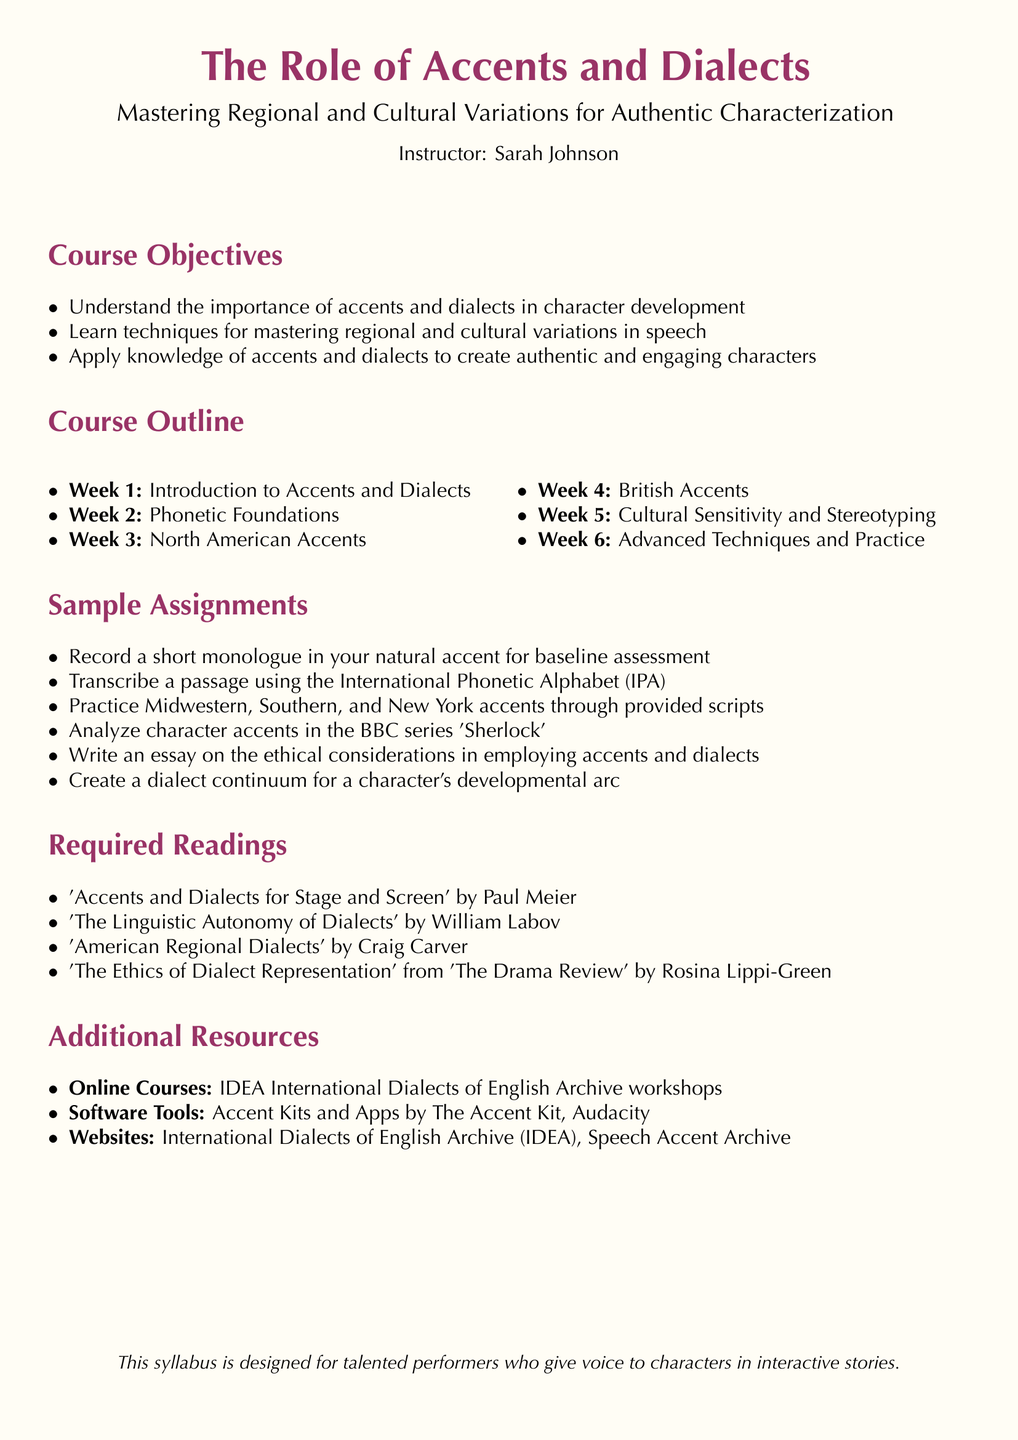What is the course title? The course title is listed at the top of the document, stating its focus on accents and dialects for performers.
Answer: The Role of Accents and Dialects Who is the instructor of the course? The instructor's name is mentioned under the course title, indicating who will lead the class.
Answer: Sarah Johnson How many weeks is the course designed for? The course outline lists weeks, which gives a clear number of instructional weeks in the syllabus.
Answer: 6 What is one of the sample assignments? A specific assignment is mentioned in the document that demonstrates what students are expected to complete as part of the course.
Answer: Record a short monologue in your natural accent for baseline assessment What is the first required reading? The syllabus includes a list of required readings, with the first title indicating an essential text for the course.
Answer: 'Accents and Dialects for Stage and Screen' by Paul Meier What week covers 'Cultural Sensitivity and Stereotyping'? The course outline breaks down topics by week, allowing us to identify when this theme is discussed.
Answer: Week 5 What type of resource are the Accent Kits classified as? The additional resources section categorizes resources to aid learning, indicating one type of resource specifically.
Answer: Software Tools What is the focus of Week 2? The course outline details the topics for each week, showing the focus for this specific week.
Answer: Phonetic Foundations 